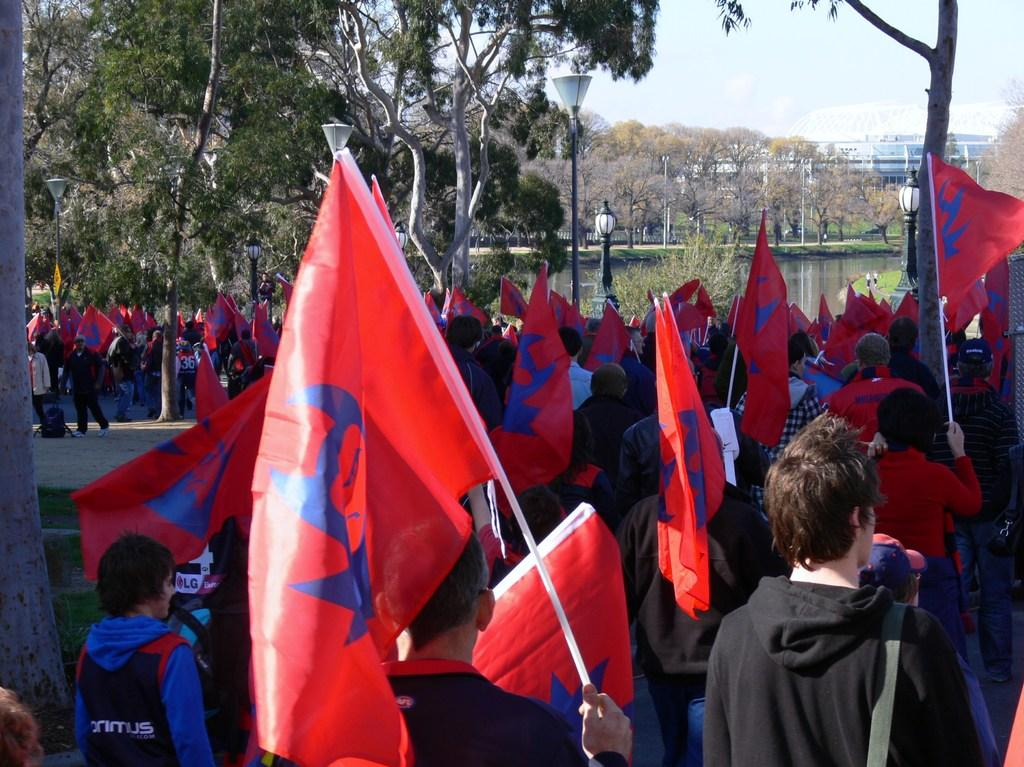What are the people in the center of the image doing? The people in the center of the image are holding flags. What can be seen in the background of the image? There are trees in the background of the image. What is visible in the image besides the people and trees? There is water, buildings, light poles, and the sky visible in the image. What news is the grandmother sharing with the people in the image? There is no grandmother present in the image, and no news is being shared. 